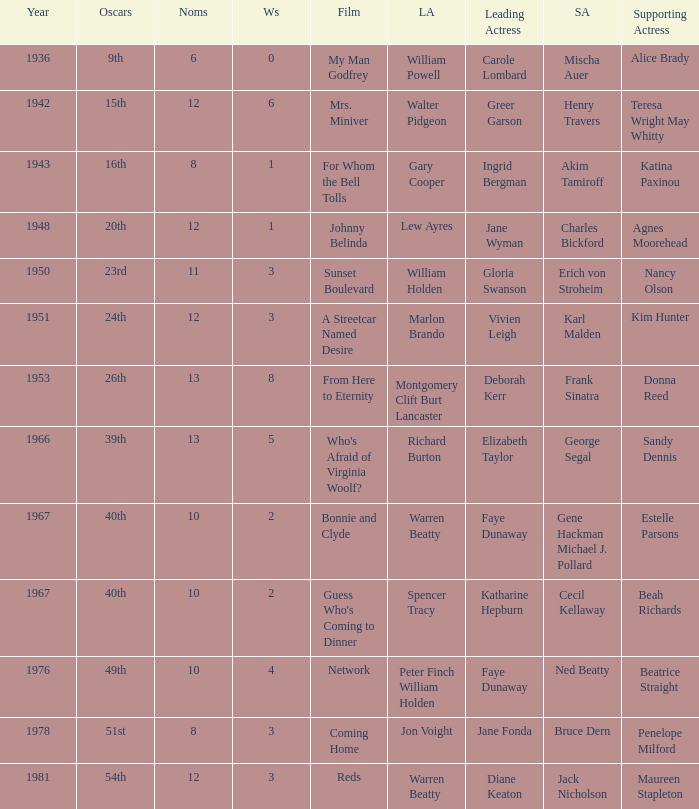Who was the supporting actress in a film with Diane Keaton as the leading actress? Maureen Stapleton. 